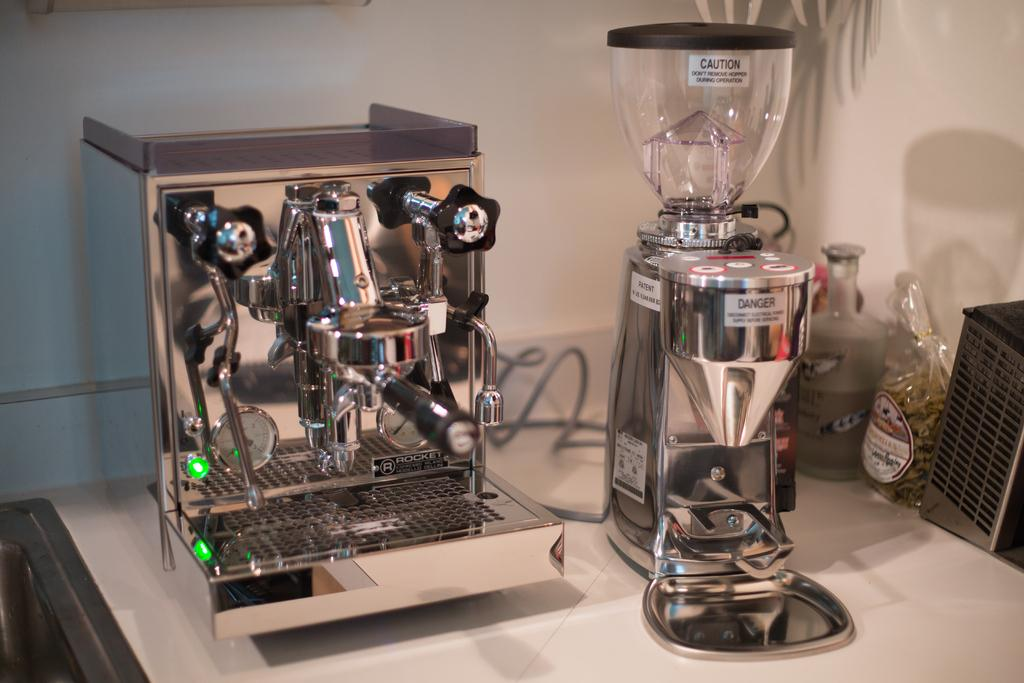<image>
Render a clear and concise summary of the photo. A counter-top with stainless steel expresso maker and press and a blender that has a sign that says Danger 